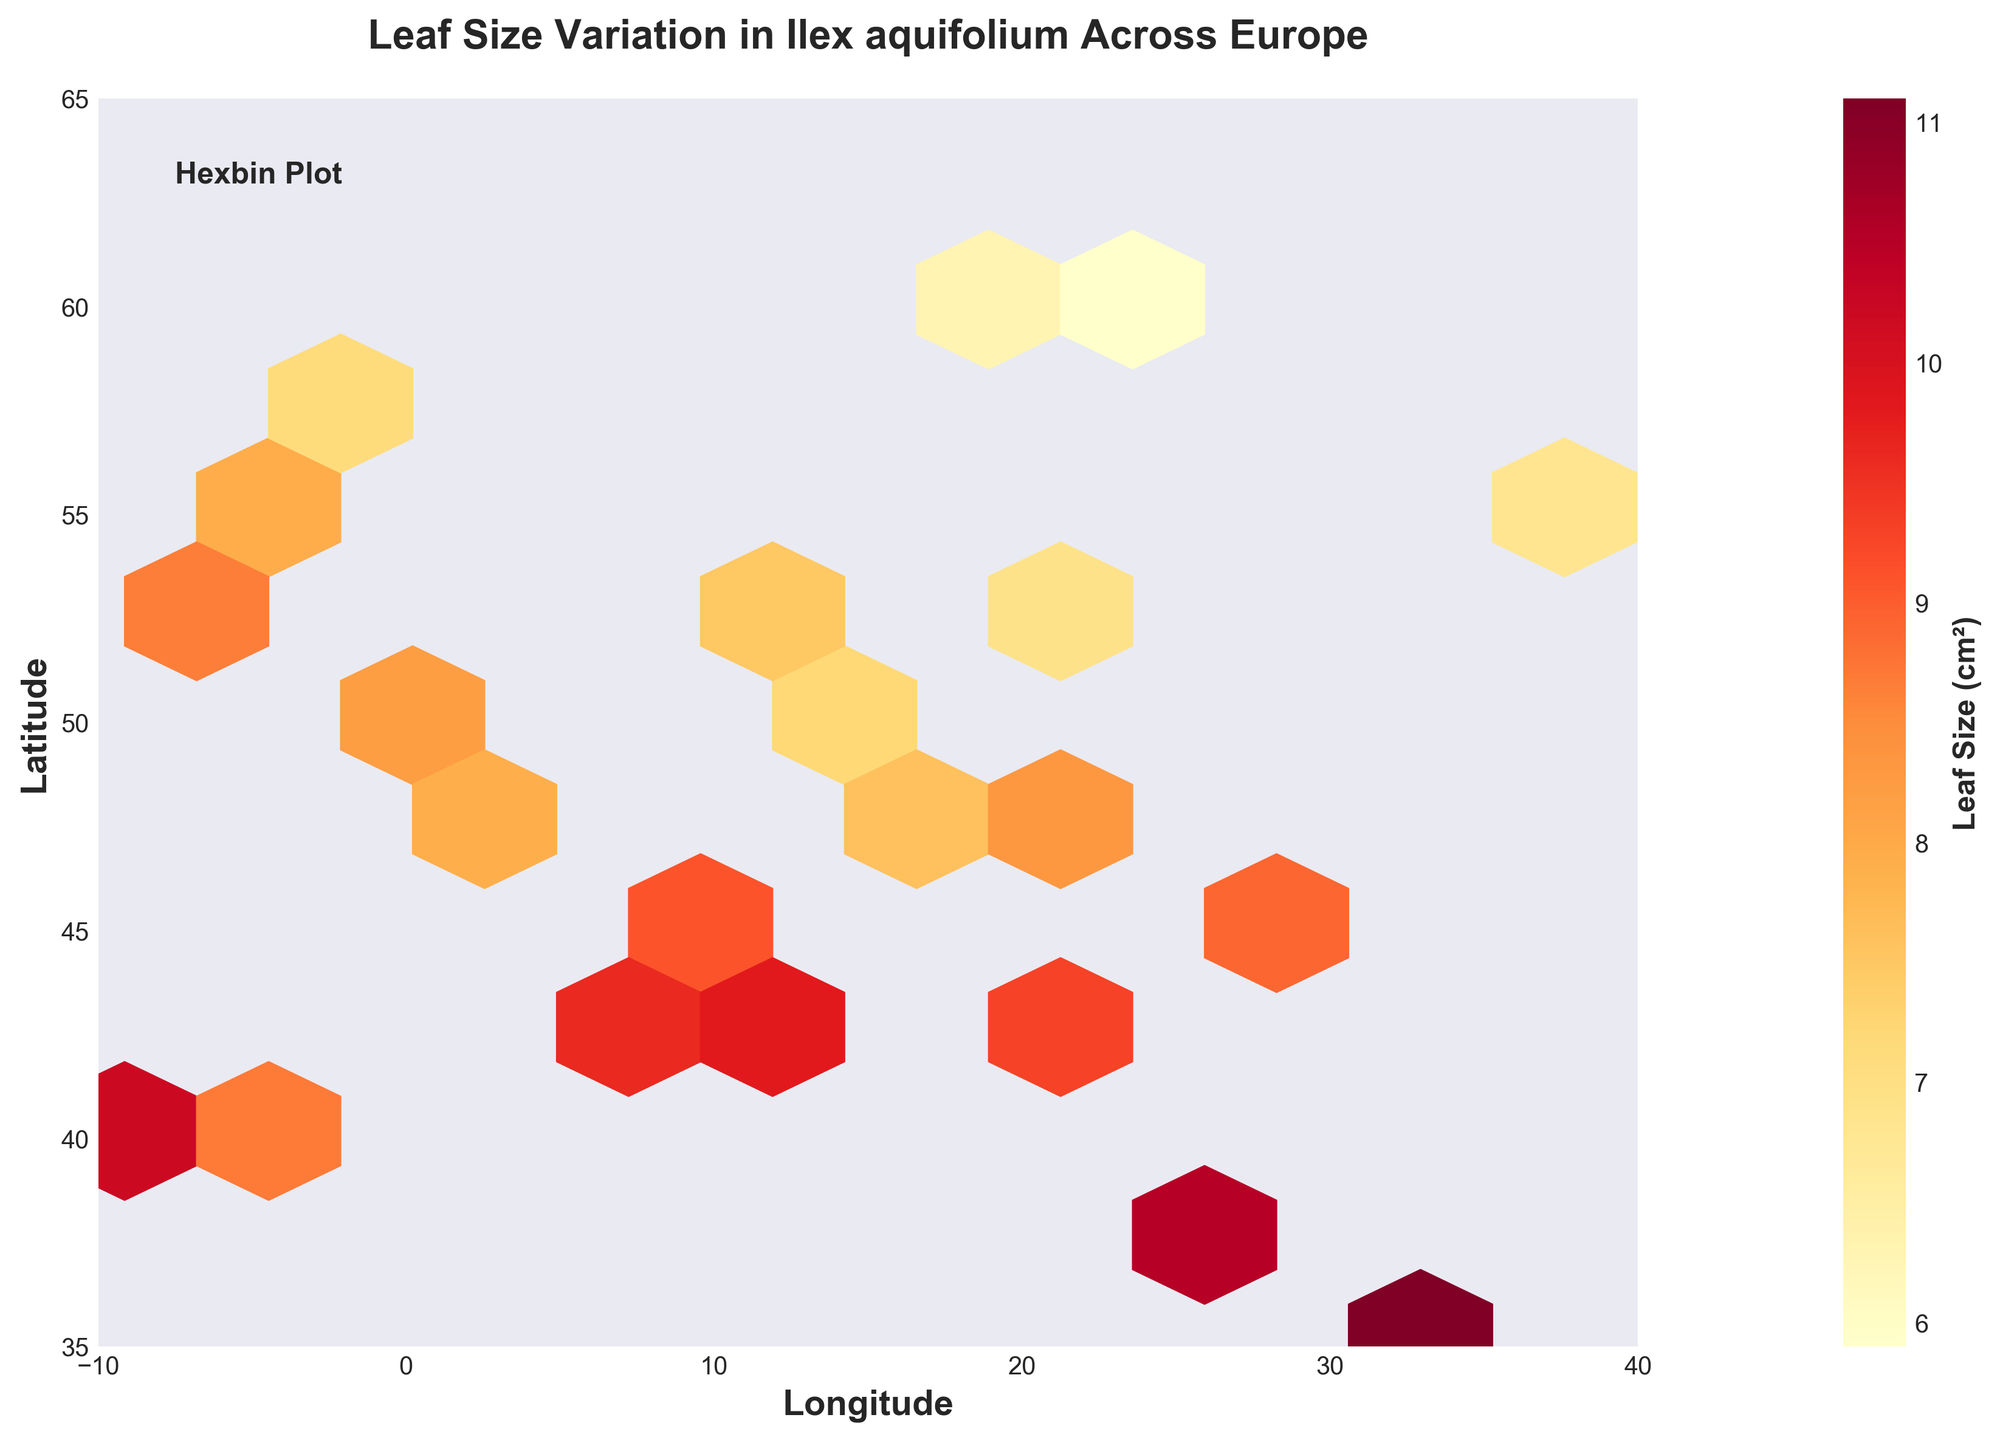what is the title of the figure? To find the title, look at the top of the figure where the main heading is typically placed.
Answer: Leaf Size Variation in Ilex aquifolium Across Europe what do the x and y axes represent? The x-axis represents Longitude, and the y-axis represents Latitude. This can be seen from the labels on each axis.
Answer: Longitude and Latitude what does the color intensity in the plot represent? The color intensity is indicated by the color scale bar, which represents the Leaf Size (cm²).
Answer: Leaf Size (cm²) how does leaf size generally vary with latitude? By observing the color variation from south to north (bottom to top), darker colors (indicating larger sizes) are more prevalent in southern regions, suggesting larger leaf sizes at lower latitudes.
Answer: Larger leaf sizes at lower latitudes are there more locations with medium leaf sizes or very large leaf sizes? Observing the plot, middle-range colors (e.g., orange) are more widely spread than the darkest red colors indicating that medium leaf sizes are more common than very large leaf sizes.
Answer: Medium leaf sizes what is the range of leaf size in the dataset? The range can be inferred from the color scale bar, indicating the smallest leaf size at 5.9 cm² and the largest at 11.1 cm².
Answer: 5.9 cm² to 11.1 cm² which geographical region has the smallest recorded leaf size? Observing the hexagons' color, the lightest color (yellow) around the latitude of 60, and longitude 24 which corresponds to Helsinki, suggests the smallest recorded leaf size.
Answer: Helsinki which location has the largest mean leaf size? By observing the darkest color hexagons and their approximate geographic coordinates, dark colors appear around the latitude of 35, and longitude 33 which corresponds to Cyprus, indicating the largest mean leaf size.
Answer: Cyprus what leaf size range is most frequent in the southwestern part of Europe? Looking at the southwestern Europe area (left-bottom corner), the prevalent color ranges from dark yellow to orange, indicating leaf sizes mostly between 8 and 10 cm².
Answer: 8 cm² to 10 cm² what is the approximate leaf size at the geographic center of the plot? The geographic center of the plot can be approximated at (15, 50). The color at this position is orange-yellow, indicating a leaf size around 7 - 9 cm².
Answer: 7 - 9 cm² 